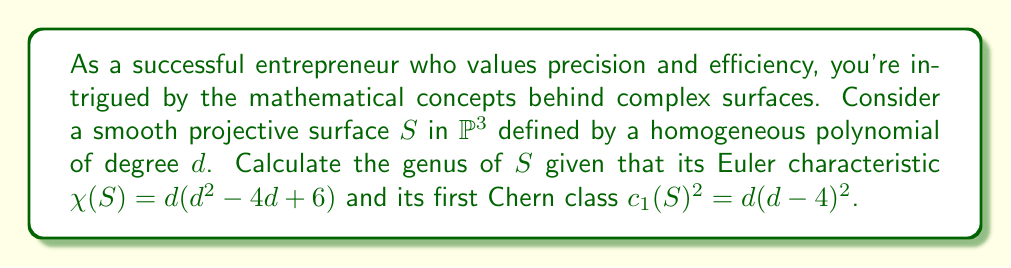Give your solution to this math problem. Let's approach this step-by-step:

1) The genus of a surface, denoted $p_g(S)$, is also known as the geometric genus. It's related to other invariants of the surface through the Noether formula:

   $$\chi(\mathcal{O}_S) = \frac{1}{12}(c_1(S)^2 + \chi(S))$$

2) Here, $\chi(\mathcal{O}_S)$ is the holomorphic Euler characteristic, which is related to the genus by:

   $$\chi(\mathcal{O}_S) = 1 - q(S) + p_g(S)$$

   where $q(S)$ is the irregularity of the surface.

3) For a smooth surface in $\mathbb{P}^3$, we know that $q(S) = 0$. Therefore:

   $$\chi(\mathcal{O}_S) = 1 + p_g(S)$$

4) Substituting this into the Noether formula:

   $$1 + p_g(S) = \frac{1}{12}(c_1(S)^2 + \chi(S))$$

5) Now, let's substitute the given values:

   $$1 + p_g(S) = \frac{1}{12}(d(d-4)^2 + d(d^2 - 4d + 6))$$

6) Simplify the right side:

   $$1 + p_g(S) = \frac{1}{12}(d^3 - 8d^2 + 16d + d^3 - 4d^2 + 6d)$$
   $$1 + p_g(S) = \frac{1}{12}(2d^3 - 12d^2 + 22d)$$
   $$1 + p_g(S) = \frac{1}{6}(d^3 - 6d^2 + 11d)$$

7) Solve for $p_g(S)$:

   $$p_g(S) = \frac{1}{6}(d^3 - 6d^2 + 11d) - 1$$
   $$p_g(S) = \frac{1}{6}(d^3 - 6d^2 + 11d - 6)$$
   $$p_g(S) = \frac{(d-1)(d-2)(d-3)}{6}$$

This final expression gives us the genus of the surface $S$ in terms of its degree $d$.
Answer: $p_g(S) = \frac{(d-1)(d-2)(d-3)}{6}$ 